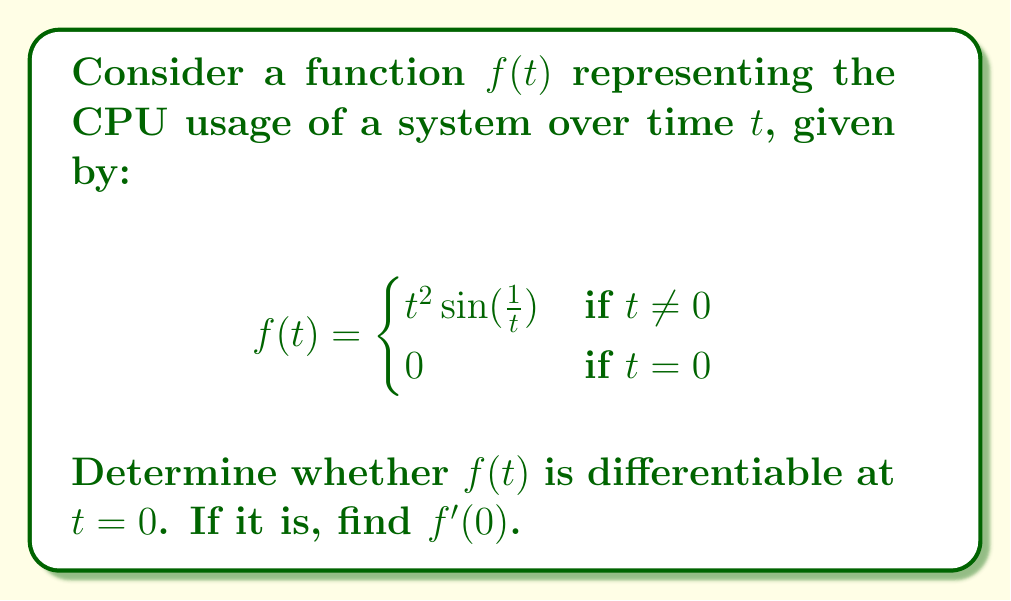Could you help me with this problem? To determine if $f(t)$ is differentiable at $t = 0$, we need to check if the limit of the difference quotient exists as $t$ approaches 0. We'll use the definition of the derivative:

$$f'(0) = \lim_{t \to 0} \frac{f(t) - f(0)}{t - 0} = \lim_{t \to 0} \frac{f(t)}{t}$$

For $t \neq 0$:

$$\lim_{t \to 0} \frac{f(t)}{t} = \lim_{t \to 0} \frac{t^2 \sin(\frac{1}{t})}{t} = \lim_{t \to 0} t \sin(\frac{1}{t})$$

To evaluate this limit, we can use the squeeze theorem. We know that $-1 \leq \sin(x) \leq 1$ for all $x$, so:

$$-|t| \leq t \sin(\frac{1}{t}) \leq |t|$$

As $t \to 0$, both $-|t|$ and $|t|$ approach 0. Therefore, by the squeeze theorem:

$$\lim_{t \to 0} t \sin(\frac{1}{t}) = 0$$

This means that the limit of the difference quotient exists and equals 0. To confirm differentiability, we also need to check if $f(t)$ is continuous at $t = 0$:

$$\lim_{t \to 0} f(t) = \lim_{t \to 0} t^2 \sin(\frac{1}{t}) = 0 = f(0)$$

Since the function is continuous at $t = 0$ and the limit of the difference quotient exists, we can conclude that $f(t)$ is differentiable at $t = 0$, and $f'(0) = 0$.
Answer: Yes, $f(t)$ is differentiable at $t = 0$, and $f'(0) = 0$. 